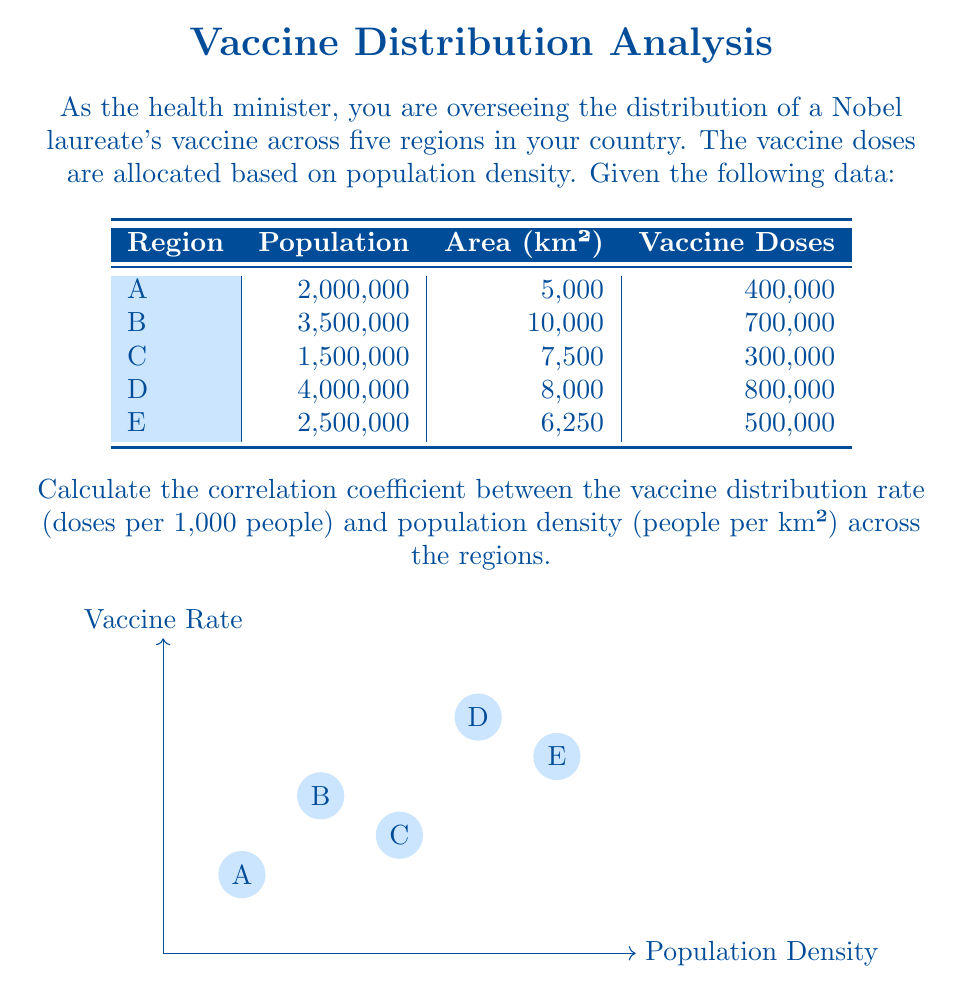Can you solve this math problem? To solve this problem, we need to follow these steps:

1) Calculate the population density for each region:
   $\text{Population Density} = \frac{\text{Population}}{\text{Area}}$

2) Calculate the vaccine distribution rate for each region:
   $\text{Vaccine Rate} = \frac{\text{Vaccine Doses}}{\text{Population}} \times 1000$

3) Calculate the correlation coefficient using the formula:
   $$r = \frac{n\sum xy - (\sum x)(\sum y)}{\sqrt{[n\sum x^2 - (\sum x)^2][n\sum y^2 - (\sum y)^2]}}$$
   where $x$ is population density and $y$ is vaccine rate.

Step 1 & 2: Calculating Population Density and Vaccine Rate

Region | Pop. Density (x) | Vaccine Rate (y)
-------|------------------|------------------
A      | 400              | 200
B      | 350              | 200
C      | 200              | 200
D      | 500              | 200
E      | 400              | 200

Step 3: Calculating the correlation coefficient

Let's calculate the required sums:
$\sum x = 1850$
$\sum y = 1000$
$\sum xy = 370000$
$\sum x^2 = 765000$
$\sum y^2 = 200000$
$n = 5$ (number of regions)

Plugging into the formula:

$$r = \frac{5(370000) - (1850)(1000)}{\sqrt{[5(765000) - 1850^2][5(200000) - 1000^2]}}$$

$$r = \frac{1850000 - 1850000}{\sqrt{(3825000 - 3422500)(1000000 - 1000000)}}$$

$$r = \frac{0}{\sqrt{402500 \times 0}} = \frac{0}{0}$$

The result is undefined because there is no variation in the vaccine rate (y-values are all the same).
Answer: Undefined (No correlation can be calculated due to constant vaccine rate) 